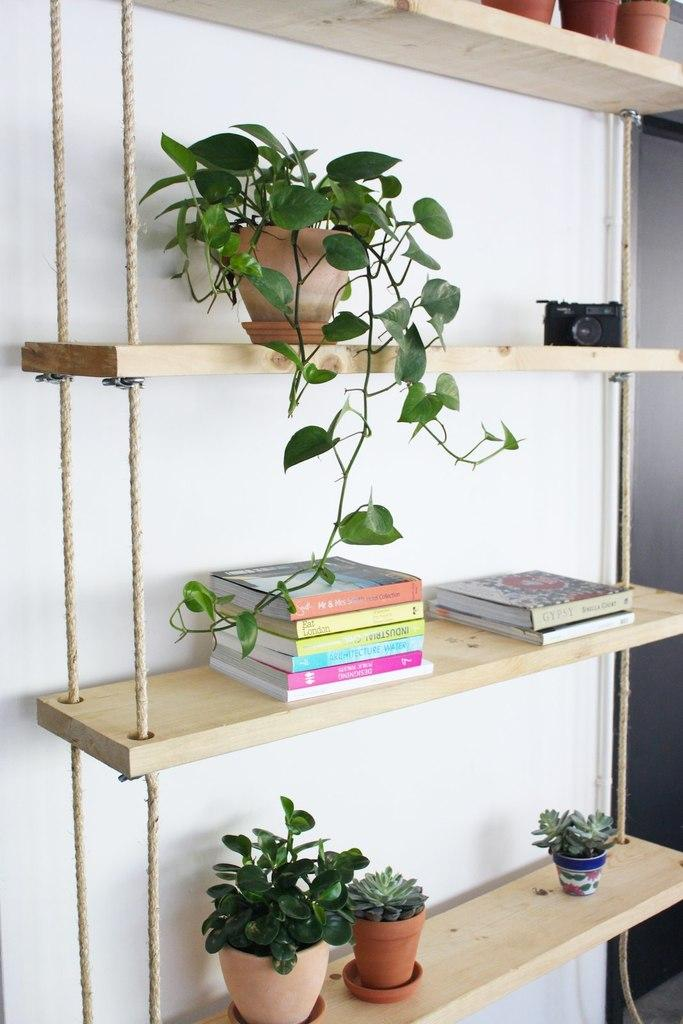What type of objects can be seen on the shelves in the image? There are flowerpots, books, and a camera in the image. What material are the shelves made of? The objects are on wooden shelves. What is the color of the background in the image? The background color is white. Are there any dinosaurs visible in the image? No, there are no dinosaurs present in the image. 